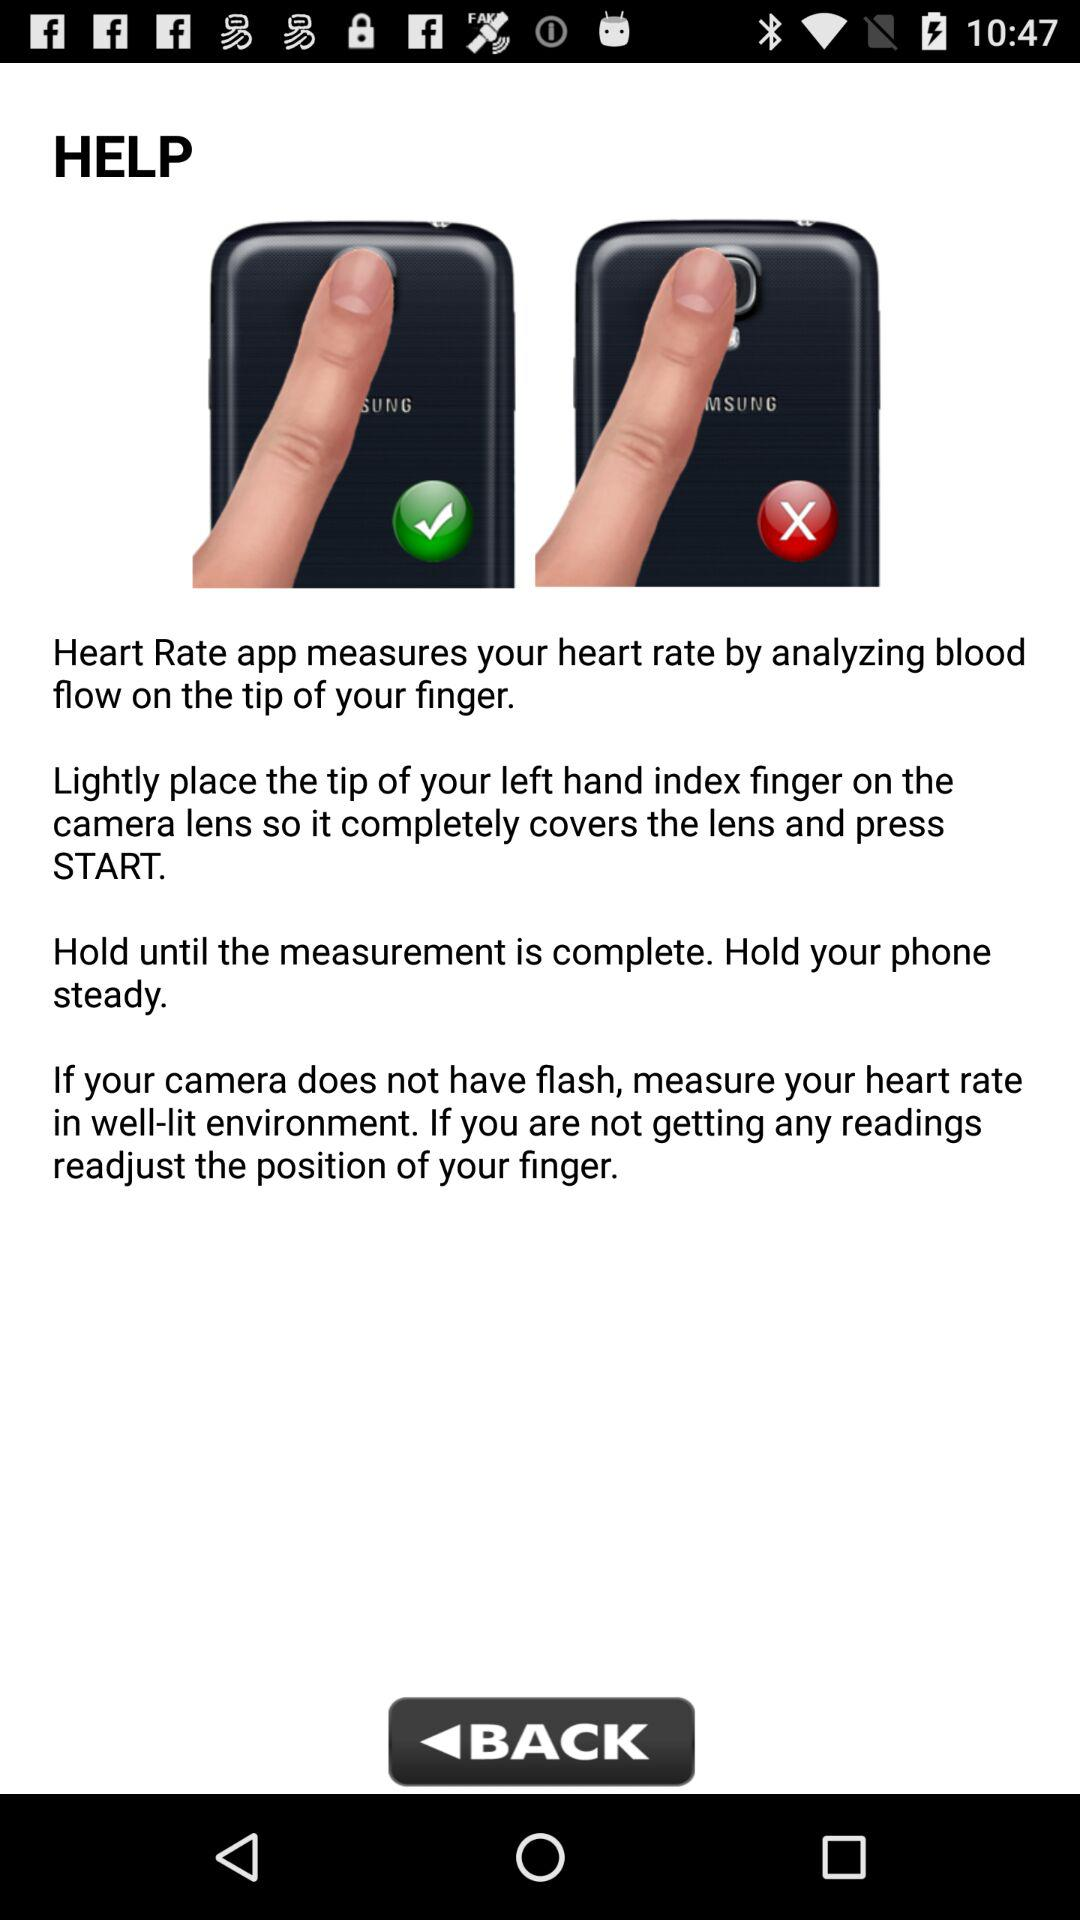How many check marks are there in the instructions?
Answer the question using a single word or phrase. 1 